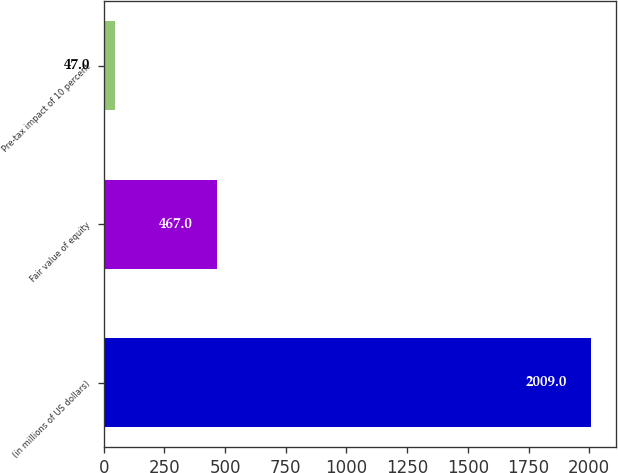<chart> <loc_0><loc_0><loc_500><loc_500><bar_chart><fcel>(in millions of US dollars)<fcel>Fair value of equity<fcel>Pre-tax impact of 10 percent<nl><fcel>2009<fcel>467<fcel>47<nl></chart> 